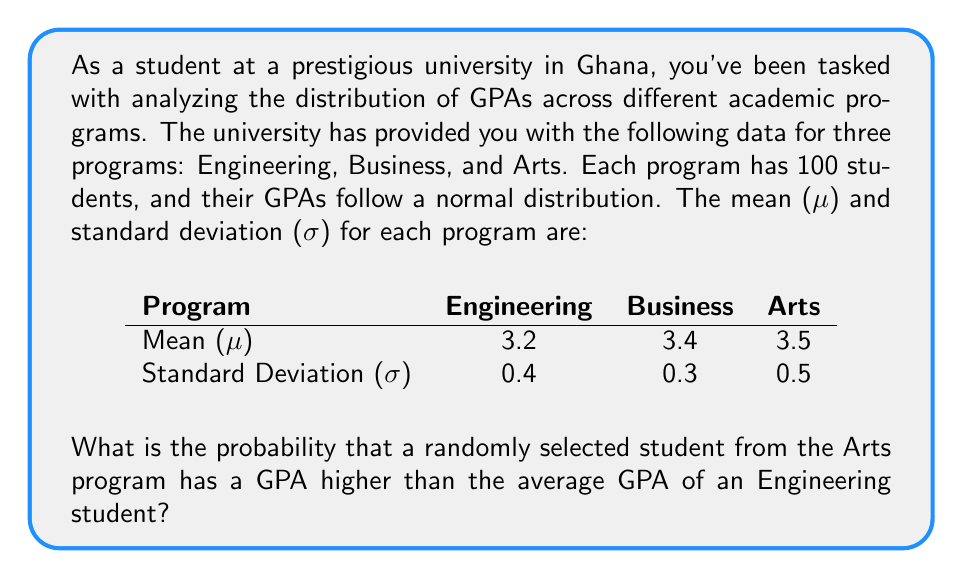Can you solve this math problem? To solve this problem, we'll follow these steps:

1) We need to find P(X > 3.2), where X is the GPA of a randomly selected Arts student.

2) We know that the GPAs in the Arts program follow a normal distribution with μ = 3.5 and σ = 0.5.

3) To standardize this problem, we need to convert the value 3.2 to a z-score:

   $$ z = \frac{x - \mu}{\sigma} = \frac{3.2 - 3.5}{0.5} = -0.6 $$

4) Now, we need to find P(Z > -0.6) where Z is the standard normal variable.

5) Using a standard normal table or calculator, we can find that:

   P(Z < -0.6) ≈ 0.2743

6) Since we want the probability of being greater than -0.6, we subtract this from 1:

   P(Z > -0.6) = 1 - P(Z < -0.6) = 1 - 0.2743 ≈ 0.7257

Therefore, the probability that a randomly selected student from the Arts program has a GPA higher than the average GPA of an Engineering student is approximately 0.7257 or 72.57%.
Answer: 0.7257 